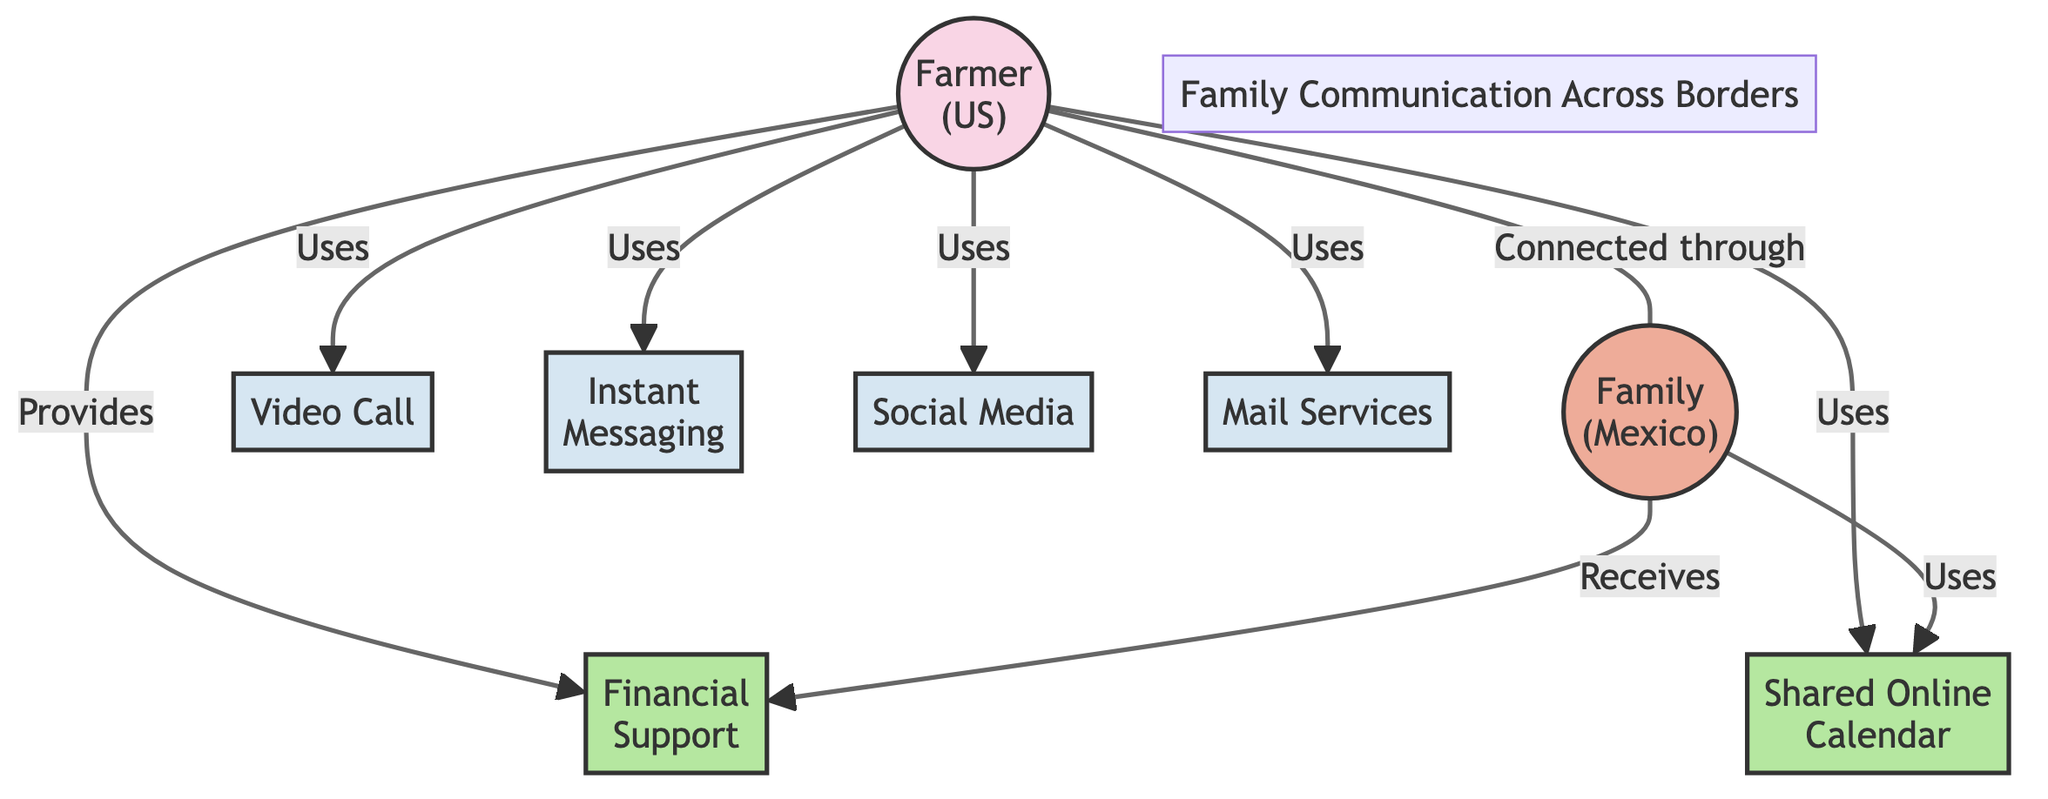What is the total number of nodes in the diagram? The diagram contains 8 distinct nodes, which include the farmer, family in Mexico, and various communication methods and resources.
Answer: 8 How many communication methods are represented in the diagram? There are 4 communication methods present: Video Call, Instant Messaging Apps, Social Media, and Mail Services.
Answer: 4 What type of relationship exists between the "Farmer (Person in the US)" and "Family in Mexico"? The relationship is defined as "Connected through," indicating a direct connection between the farmer and their family.
Answer: Connected through Which resource does the "Farmer (Person in the US)" provide to their family? The "Farmer (Person in the US)" provides "Financial Support," which is a type of resource.
Answer: Financial Support Which two nodes are connected by the "Uses" relationship? There are multiple connections for the "Farmer (Person in the US)" that include communication methods (Video Call, Instant Messaging Apps, Social Media, Mail Services, Shared Online Calendar).
Answer: Video Call, Instant Messaging Apps, Social Media, Mail Services, Shared Online Calendar What do the nodes "Shared Online Calendar" and "Family in Mexico" have in common? Both utilize the "Shared Online Calendar," demonstrating that the family in Mexico uses this resource as well as the Farmer.
Answer: Uses If the "Farmer (Person in the US)" uses "Social Media," what type of node does this represent? The use of "Social Media" by the "Farmer (Person in the US)" represents a communication method node.
Answer: communication method How many edges come out of the "Family in Mexico" node? The "Family in Mexico" has two outgoing edges: one to "Financial Support" and one to "Shared Online Calendar."
Answer: 2 